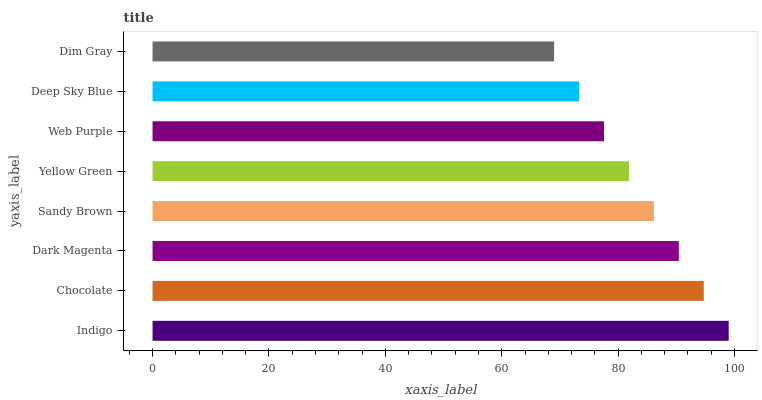Is Dim Gray the minimum?
Answer yes or no. Yes. Is Indigo the maximum?
Answer yes or no. Yes. Is Chocolate the minimum?
Answer yes or no. No. Is Chocolate the maximum?
Answer yes or no. No. Is Indigo greater than Chocolate?
Answer yes or no. Yes. Is Chocolate less than Indigo?
Answer yes or no. Yes. Is Chocolate greater than Indigo?
Answer yes or no. No. Is Indigo less than Chocolate?
Answer yes or no. No. Is Sandy Brown the high median?
Answer yes or no. Yes. Is Yellow Green the low median?
Answer yes or no. Yes. Is Dark Magenta the high median?
Answer yes or no. No. Is Indigo the low median?
Answer yes or no. No. 